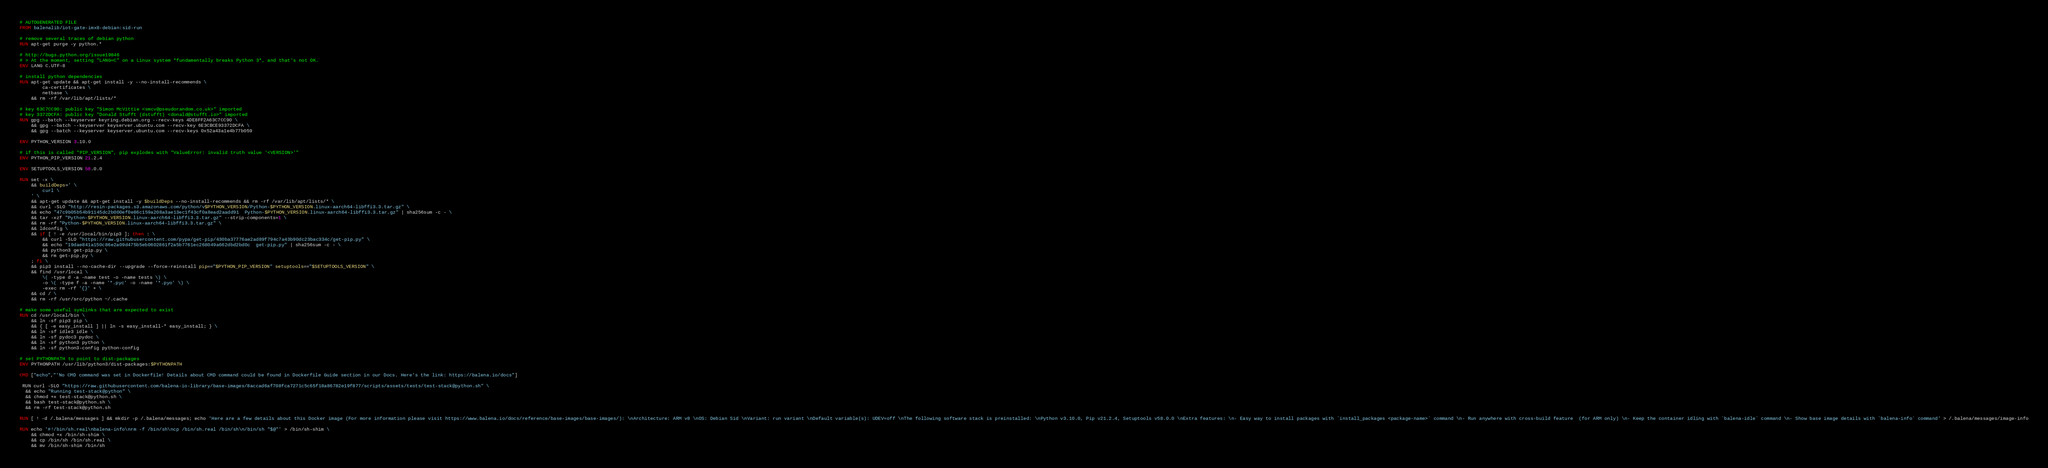<code> <loc_0><loc_0><loc_500><loc_500><_Dockerfile_># AUTOGENERATED FILE
FROM balenalib/iot-gate-imx8-debian:sid-run

# remove several traces of debian python
RUN apt-get purge -y python.*

# http://bugs.python.org/issue19846
# > At the moment, setting "LANG=C" on a Linux system *fundamentally breaks Python 3*, and that's not OK.
ENV LANG C.UTF-8

# install python dependencies
RUN apt-get update && apt-get install -y --no-install-recommends \
		ca-certificates \
		netbase \
	&& rm -rf /var/lib/apt/lists/*

# key 63C7CC90: public key "Simon McVittie <smcv@pseudorandom.co.uk>" imported
# key 3372DCFA: public key "Donald Stufft (dstufft) <donald@stufft.io>" imported
RUN gpg --batch --keyserver keyring.debian.org --recv-keys 4DE8FF2A63C7CC90 \
	&& gpg --batch --keyserver keyserver.ubuntu.com --recv-key 6E3CBCE93372DCFA \
	&& gpg --batch --keyserver keyserver.ubuntu.com --recv-keys 0x52a43a1e4b77b059

ENV PYTHON_VERSION 3.10.0

# if this is called "PIP_VERSION", pip explodes with "ValueError: invalid truth value '<VERSION>'"
ENV PYTHON_PIP_VERSION 21.2.4

ENV SETUPTOOLS_VERSION 58.0.0

RUN set -x \
	&& buildDeps=' \
		curl \
	' \
	&& apt-get update && apt-get install -y $buildDeps --no-install-recommends && rm -rf /var/lib/apt/lists/* \
	&& curl -SLO "http://resin-packages.s3.amazonaws.com/python/v$PYTHON_VERSION/Python-$PYTHON_VERSION.linux-aarch64-libffi3.3.tar.gz" \
	&& echo "47c9b05b54b91145dc2b000ef0e86c159a208a3ae13ec1f43cf0a8ead2aadd91  Python-$PYTHON_VERSION.linux-aarch64-libffi3.3.tar.gz" | sha256sum -c - \
	&& tar -xzf "Python-$PYTHON_VERSION.linux-aarch64-libffi3.3.tar.gz" --strip-components=1 \
	&& rm -rf "Python-$PYTHON_VERSION.linux-aarch64-libffi3.3.tar.gz" \
	&& ldconfig \
	&& if [ ! -e /usr/local/bin/pip3 ]; then : \
		&& curl -SLO "https://raw.githubusercontent.com/pypa/get-pip/430ba37776ae2ad89f794c7a43b90dc23bac334c/get-pip.py" \
		&& echo "19dae841a150c86e2a09d475b5eb0602861f2a5b7761ec268049a662dbd2bd0c  get-pip.py" | sha256sum -c - \
		&& python3 get-pip.py \
		&& rm get-pip.py \
	; fi \
	&& pip3 install --no-cache-dir --upgrade --force-reinstall pip=="$PYTHON_PIP_VERSION" setuptools=="$SETUPTOOLS_VERSION" \
	&& find /usr/local \
		\( -type d -a -name test -o -name tests \) \
		-o \( -type f -a -name '*.pyc' -o -name '*.pyo' \) \
		-exec rm -rf '{}' + \
	&& cd / \
	&& rm -rf /usr/src/python ~/.cache

# make some useful symlinks that are expected to exist
RUN cd /usr/local/bin \
	&& ln -sf pip3 pip \
	&& { [ -e easy_install ] || ln -s easy_install-* easy_install; } \
	&& ln -sf idle3 idle \
	&& ln -sf pydoc3 pydoc \
	&& ln -sf python3 python \
	&& ln -sf python3-config python-config

# set PYTHONPATH to point to dist-packages
ENV PYTHONPATH /usr/lib/python3/dist-packages:$PYTHONPATH

CMD ["echo","'No CMD command was set in Dockerfile! Details about CMD command could be found in Dockerfile Guide section in our Docs. Here's the link: https://balena.io/docs"]

 RUN curl -SLO "https://raw.githubusercontent.com/balena-io-library/base-images/8accad6af708fca7271c5c65f18a86782e19f877/scripts/assets/tests/test-stack@python.sh" \
  && echo "Running test-stack@python" \
  && chmod +x test-stack@python.sh \
  && bash test-stack@python.sh \
  && rm -rf test-stack@python.sh 

RUN [ ! -d /.balena/messages ] && mkdir -p /.balena/messages; echo 'Here are a few details about this Docker image (For more information please visit https://www.balena.io/docs/reference/base-images/base-images/): \nArchitecture: ARM v8 \nOS: Debian Sid \nVariant: run variant \nDefault variable(s): UDEV=off \nThe following software stack is preinstalled: \nPython v3.10.0, Pip v21.2.4, Setuptools v58.0.0 \nExtra features: \n- Easy way to install packages with `install_packages <package-name>` command \n- Run anywhere with cross-build feature  (for ARM only) \n- Keep the container idling with `balena-idle` command \n- Show base image details with `balena-info` command' > /.balena/messages/image-info

RUN echo '#!/bin/sh.real\nbalena-info\nrm -f /bin/sh\ncp /bin/sh.real /bin/sh\n/bin/sh "$@"' > /bin/sh-shim \
	&& chmod +x /bin/sh-shim \
	&& cp /bin/sh /bin/sh.real \
	&& mv /bin/sh-shim /bin/sh</code> 